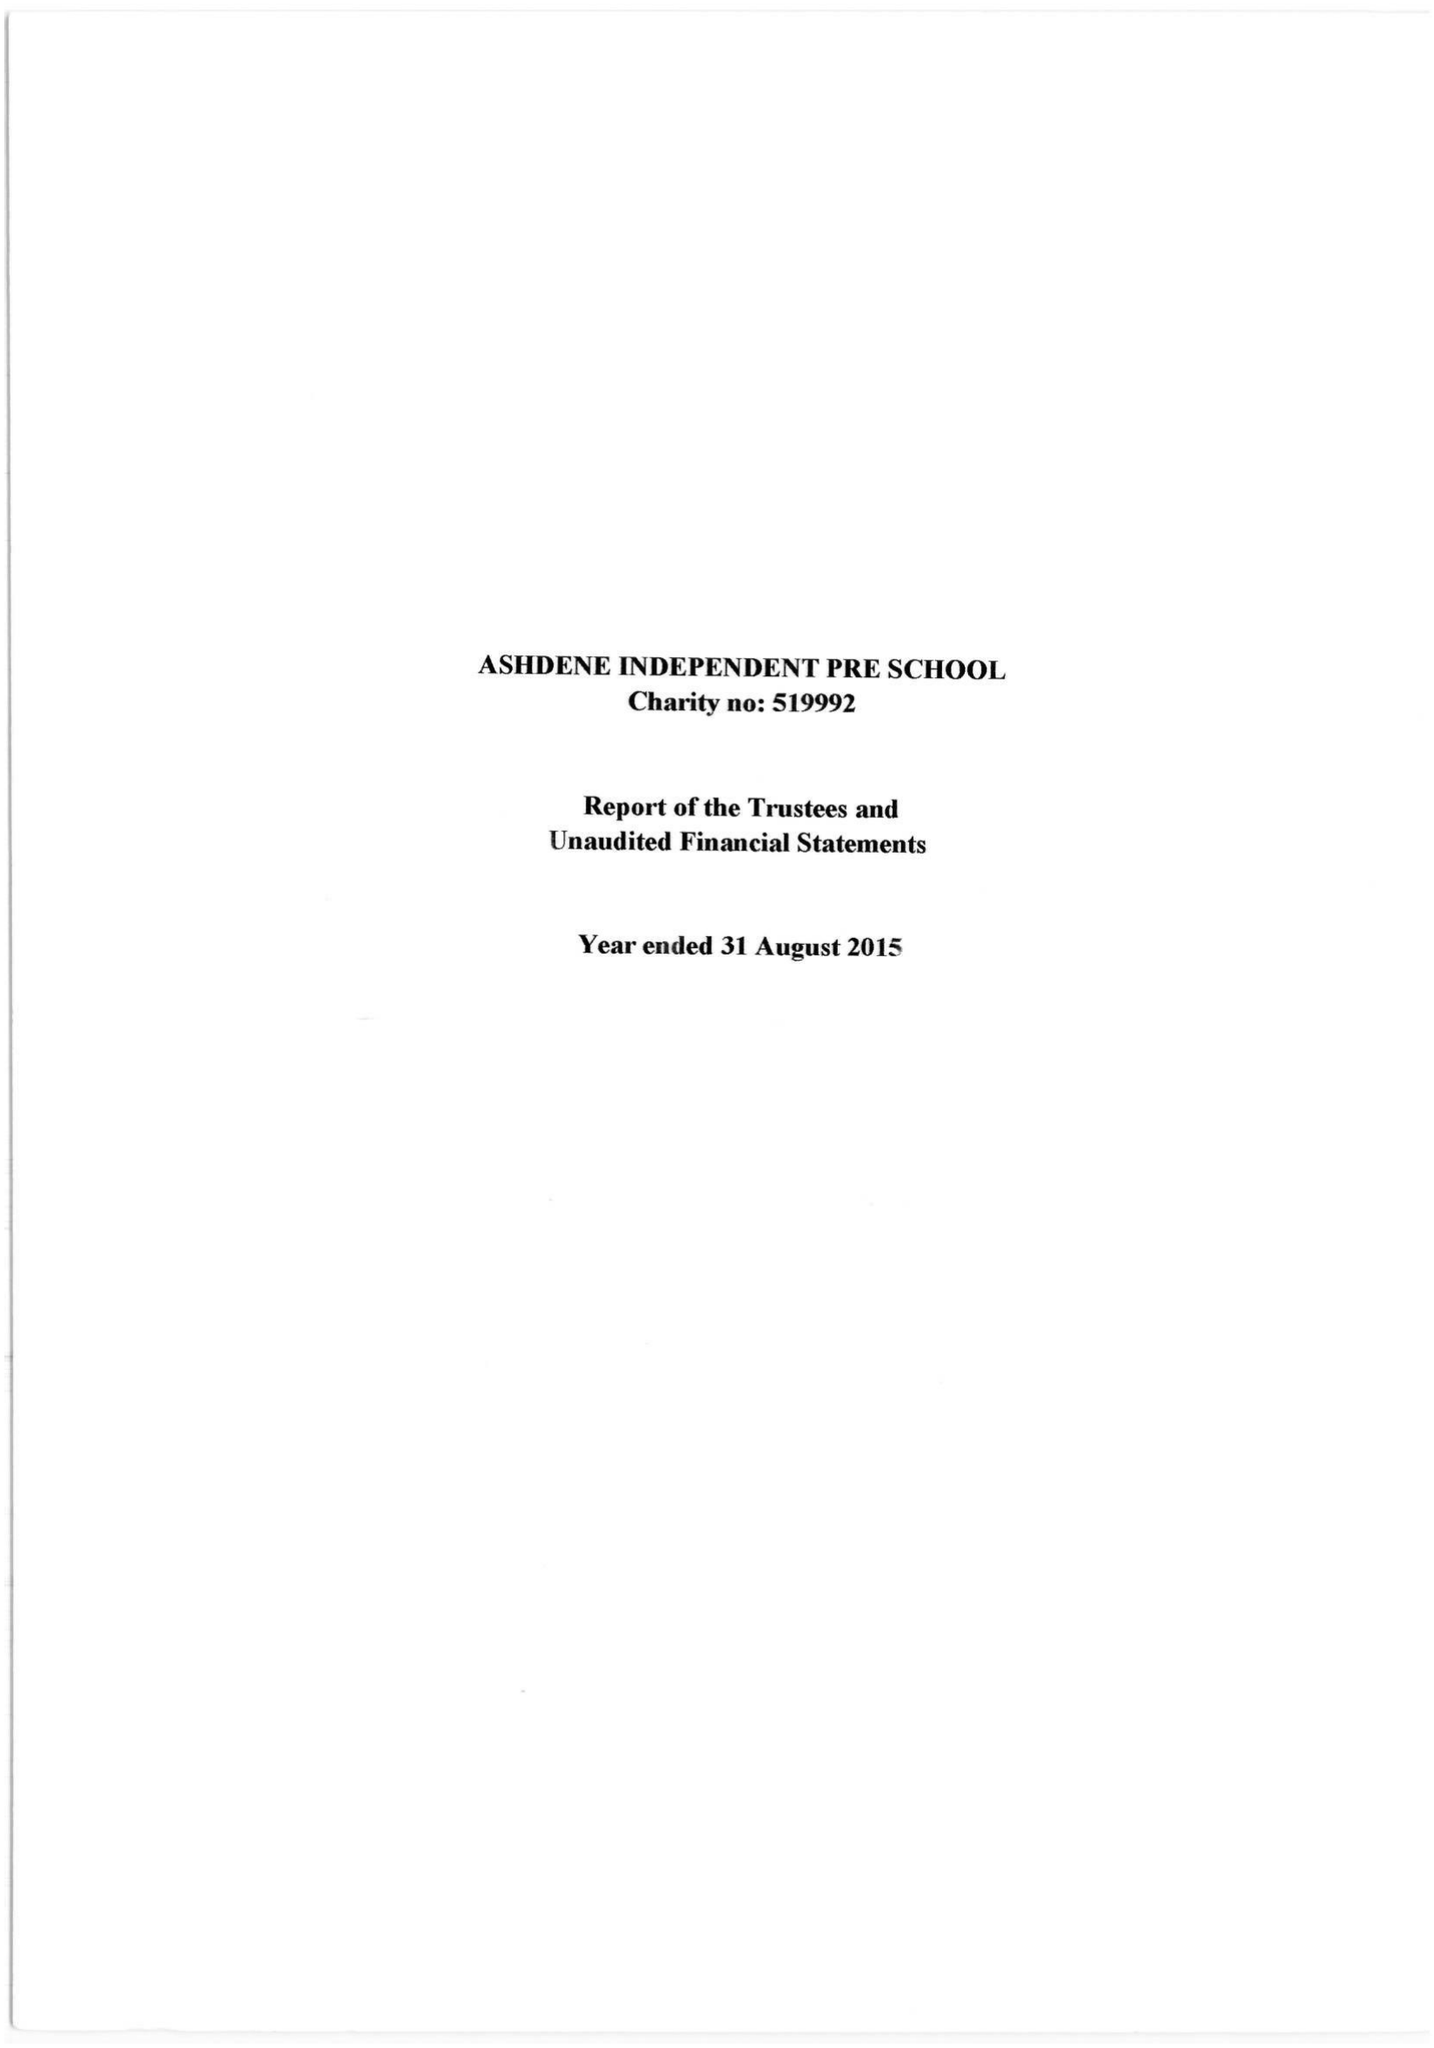What is the value for the address__postcode?
Answer the question using a single word or phrase. None 